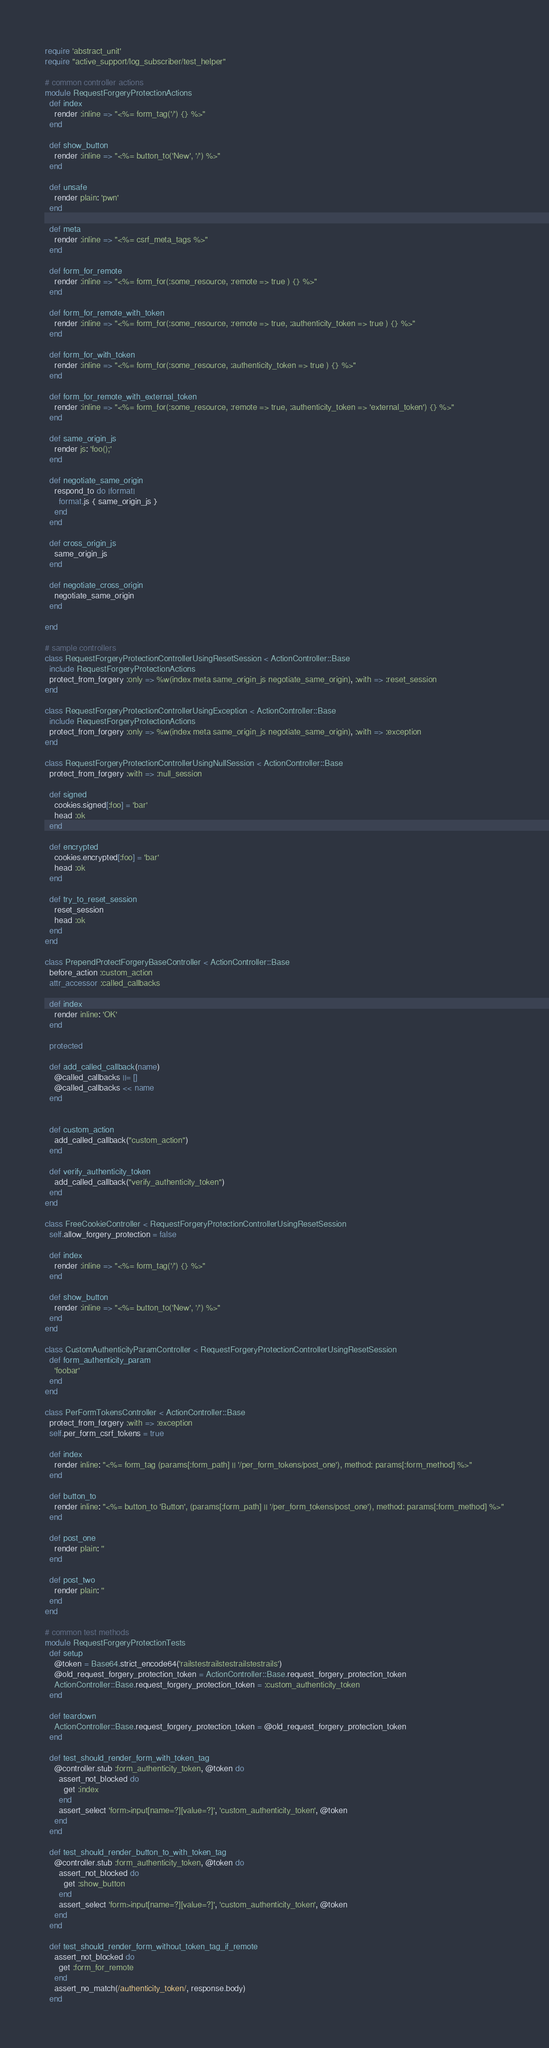<code> <loc_0><loc_0><loc_500><loc_500><_Ruby_>require 'abstract_unit'
require "active_support/log_subscriber/test_helper"

# common controller actions
module RequestForgeryProtectionActions
  def index
    render :inline => "<%= form_tag('/') {} %>"
  end

  def show_button
    render :inline => "<%= button_to('New', '/') %>"
  end

  def unsafe
    render plain: 'pwn'
  end

  def meta
    render :inline => "<%= csrf_meta_tags %>"
  end

  def form_for_remote
    render :inline => "<%= form_for(:some_resource, :remote => true ) {} %>"
  end

  def form_for_remote_with_token
    render :inline => "<%= form_for(:some_resource, :remote => true, :authenticity_token => true ) {} %>"
  end

  def form_for_with_token
    render :inline => "<%= form_for(:some_resource, :authenticity_token => true ) {} %>"
  end

  def form_for_remote_with_external_token
    render :inline => "<%= form_for(:some_resource, :remote => true, :authenticity_token => 'external_token') {} %>"
  end

  def same_origin_js
    render js: 'foo();'
  end

  def negotiate_same_origin
    respond_to do |format|
      format.js { same_origin_js }
    end
  end

  def cross_origin_js
    same_origin_js
  end

  def negotiate_cross_origin
    negotiate_same_origin
  end

end

# sample controllers
class RequestForgeryProtectionControllerUsingResetSession < ActionController::Base
  include RequestForgeryProtectionActions
  protect_from_forgery :only => %w(index meta same_origin_js negotiate_same_origin), :with => :reset_session
end

class RequestForgeryProtectionControllerUsingException < ActionController::Base
  include RequestForgeryProtectionActions
  protect_from_forgery :only => %w(index meta same_origin_js negotiate_same_origin), :with => :exception
end

class RequestForgeryProtectionControllerUsingNullSession < ActionController::Base
  protect_from_forgery :with => :null_session

  def signed
    cookies.signed[:foo] = 'bar'
    head :ok
  end

  def encrypted
    cookies.encrypted[:foo] = 'bar'
    head :ok
  end

  def try_to_reset_session
    reset_session
    head :ok
  end
end

class PrependProtectForgeryBaseController < ActionController::Base
  before_action :custom_action
  attr_accessor :called_callbacks

  def index
    render inline: 'OK'
  end

  protected

  def add_called_callback(name)
    @called_callbacks ||= []
    @called_callbacks << name
  end


  def custom_action
    add_called_callback("custom_action")
  end

  def verify_authenticity_token
    add_called_callback("verify_authenticity_token")
  end
end

class FreeCookieController < RequestForgeryProtectionControllerUsingResetSession
  self.allow_forgery_protection = false

  def index
    render :inline => "<%= form_tag('/') {} %>"
  end

  def show_button
    render :inline => "<%= button_to('New', '/') %>"
  end
end

class CustomAuthenticityParamController < RequestForgeryProtectionControllerUsingResetSession
  def form_authenticity_param
    'foobar'
  end
end

class PerFormTokensController < ActionController::Base
  protect_from_forgery :with => :exception
  self.per_form_csrf_tokens = true

  def index
    render inline: "<%= form_tag (params[:form_path] || '/per_form_tokens/post_one'), method: params[:form_method] %>"
  end

  def button_to
    render inline: "<%= button_to 'Button', (params[:form_path] || '/per_form_tokens/post_one'), method: params[:form_method] %>"
  end

  def post_one
    render plain: ''
  end

  def post_two
    render plain: ''
  end
end

# common test methods
module RequestForgeryProtectionTests
  def setup
    @token = Base64.strict_encode64('railstestrailstestrailstestrails')
    @old_request_forgery_protection_token = ActionController::Base.request_forgery_protection_token
    ActionController::Base.request_forgery_protection_token = :custom_authenticity_token
  end

  def teardown
    ActionController::Base.request_forgery_protection_token = @old_request_forgery_protection_token
  end

  def test_should_render_form_with_token_tag
    @controller.stub :form_authenticity_token, @token do
      assert_not_blocked do
        get :index
      end
      assert_select 'form>input[name=?][value=?]', 'custom_authenticity_token', @token
    end
  end

  def test_should_render_button_to_with_token_tag
    @controller.stub :form_authenticity_token, @token do
      assert_not_blocked do
        get :show_button
      end
      assert_select 'form>input[name=?][value=?]', 'custom_authenticity_token', @token
    end
  end

  def test_should_render_form_without_token_tag_if_remote
    assert_not_blocked do
      get :form_for_remote
    end
    assert_no_match(/authenticity_token/, response.body)
  end
</code> 